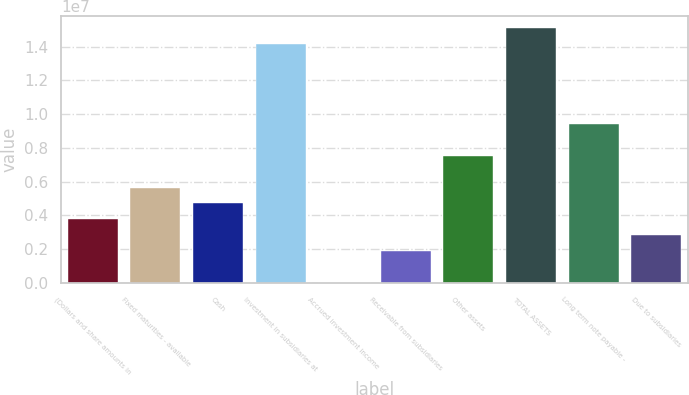Convert chart to OTSL. <chart><loc_0><loc_0><loc_500><loc_500><bar_chart><fcel>(Dollars and share amounts in<fcel>Fixed maturities - available<fcel>Cash<fcel>Investment in subsidiaries at<fcel>Accrued investment income<fcel>Receivable from subsidiaries<fcel>Other assets<fcel>TOTAL ASSETS<fcel>Long term note payable -<fcel>Due to subsidiaries<nl><fcel>3.76918e+06<fcel>5.65377e+06<fcel>4.71148e+06<fcel>1.41344e+07<fcel>20<fcel>1.8846e+06<fcel>7.53835e+06<fcel>1.50767e+07<fcel>9.42293e+06<fcel>2.82689e+06<nl></chart> 